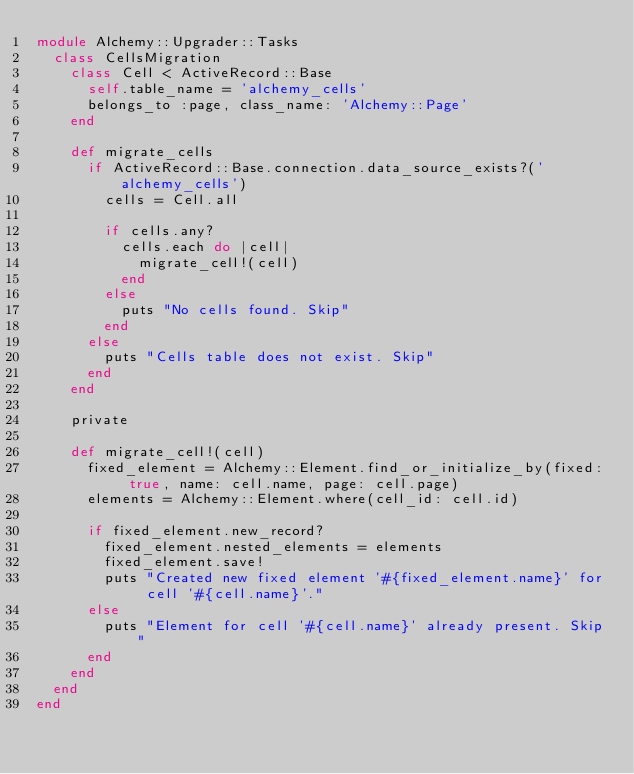<code> <loc_0><loc_0><loc_500><loc_500><_Ruby_>module Alchemy::Upgrader::Tasks
  class CellsMigration
    class Cell < ActiveRecord::Base
      self.table_name = 'alchemy_cells'
      belongs_to :page, class_name: 'Alchemy::Page'
    end

    def migrate_cells
      if ActiveRecord::Base.connection.data_source_exists?('alchemy_cells')
        cells = Cell.all

        if cells.any?
          cells.each do |cell|
            migrate_cell!(cell)
          end
        else
          puts "No cells found. Skip"
        end
      else
        puts "Cells table does not exist. Skip"
      end
    end

    private

    def migrate_cell!(cell)
      fixed_element = Alchemy::Element.find_or_initialize_by(fixed: true, name: cell.name, page: cell.page)
      elements = Alchemy::Element.where(cell_id: cell.id)

      if fixed_element.new_record?
        fixed_element.nested_elements = elements
        fixed_element.save!
        puts "Created new fixed element '#{fixed_element.name}' for cell '#{cell.name}'."
      else
        puts "Element for cell '#{cell.name}' already present. Skip"
      end
    end
  end
end
</code> 